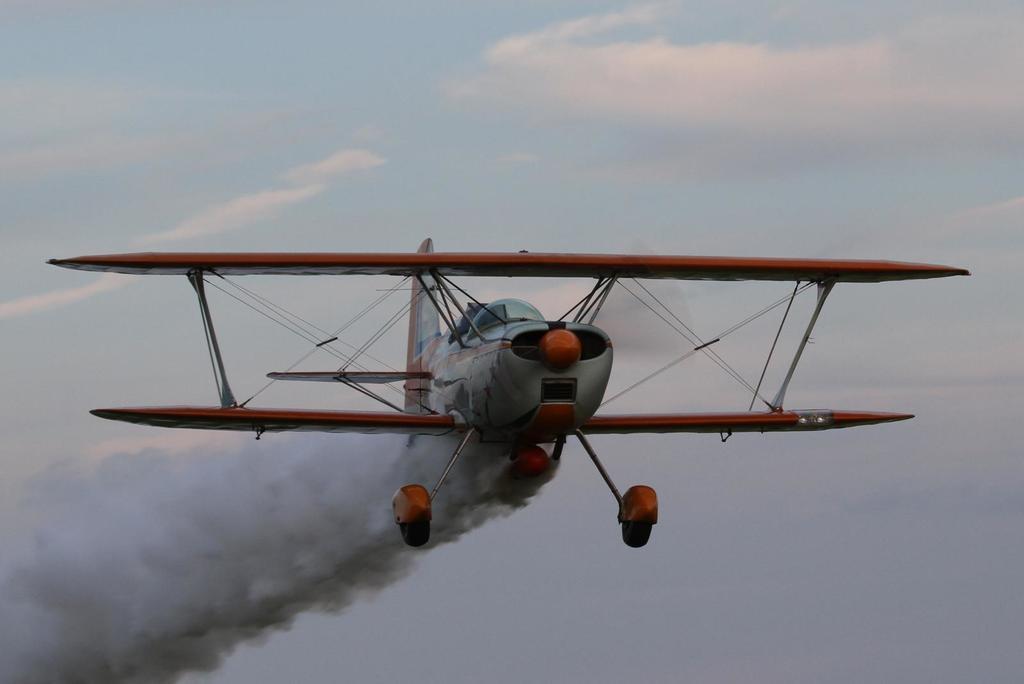Could you give a brief overview of what you see in this image? This picture is clicked outside. In the center there is an aircraft flying in the sky and seems to be releasing smoke. In the background there is a sky. 